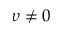Convert formula to latex. <formula><loc_0><loc_0><loc_500><loc_500>\upsilon \neq 0</formula> 